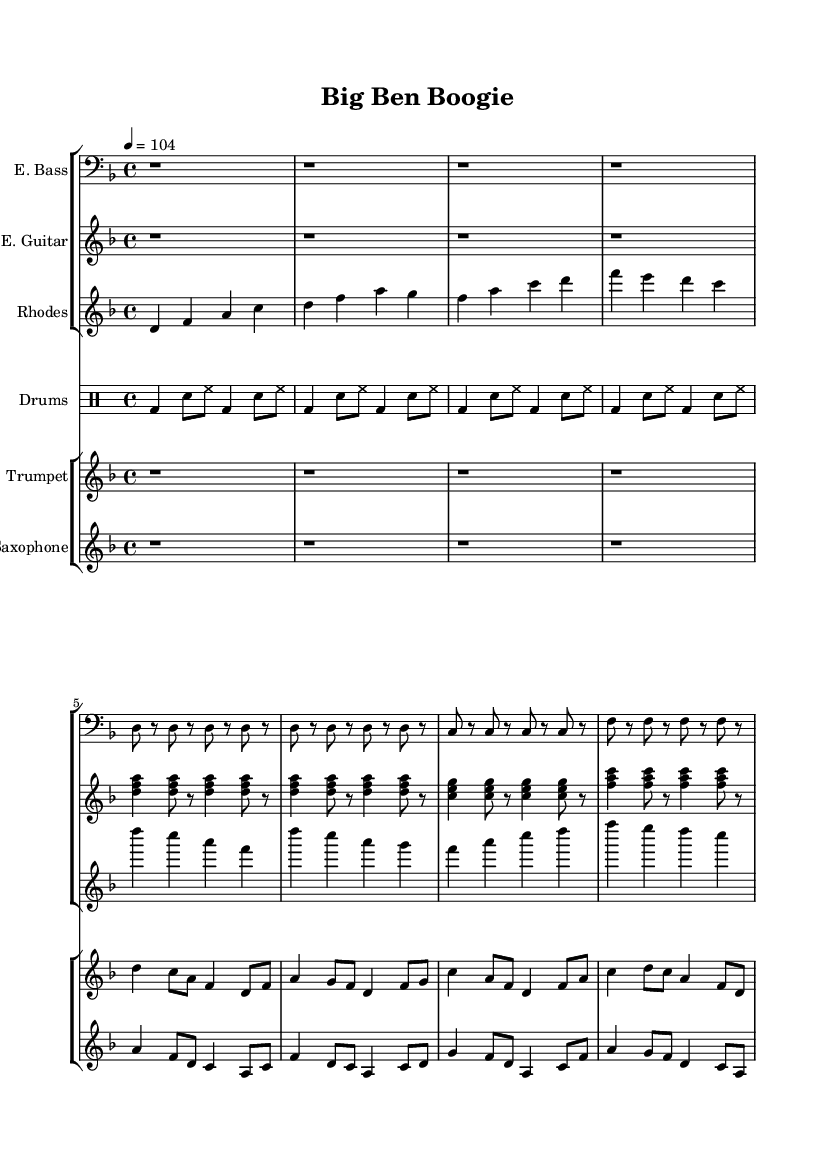what is the key signature of this music? The key signature is D minor, which is indicated by one flat (B flat) in the key signature section on the left side of the staff.
Answer: D minor what is the time signature of this music? The time signature is 4/4, which is shown at the beginning of the score, indicating four beats per measure and a quarter note receives one beat.
Answer: 4/4 what is the tempo marking for this piece? The tempo marking is 104 bpm, denoted by the tempo indication under the global section, specifying the piece should be played at a speed of 104 beats per minute.
Answer: 104 how many instruments are featured in this composition? There are five different instruments indicated in the score: Electric Bass, Electric Guitar, Rhodes Piano, Drums, Trumpet, and Saxophone, which are all listed separately in the staff group sections.
Answer: Five what is the rhythmic pattern characteristic of the drum kit in this piece? The drum pattern consists of a bass drum on beats 1 and 3, with snare and hi-hat alternating in eighth notes, creating a standard funk groove rhythm that emphasizes the backbeat.
Answer: Funk groove which section contains the melodic line for the trumpet? The trumpet part is located in a separate staff group designated for "Trumpet," as indicated by the instrument name at the beginning of that staff, containing the melody throughout the sections.
Answer: Trumpet staff what is the dominant chord used in the electric guitar part? The electric guitar primarily uses D minor chords, as seen when grouping the chord tones of D, F, and A, which are repeated throughout the sections to create harmonic structure.
Answer: D minor 